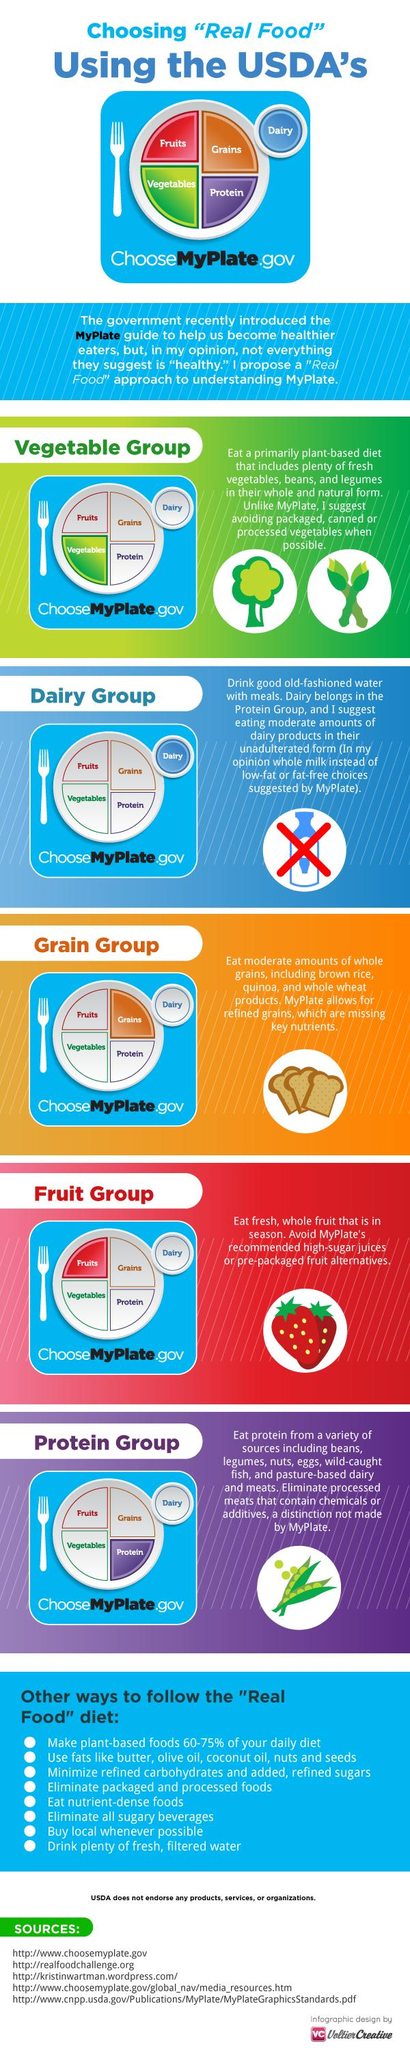Give some essential details in this illustration. The third food group mentioned in the graphic is the Grain group. Eggs are classified under the protein food group. The food group that has been represented by the color green in the image is the vegetable group. Processed meats that contain chemicals or additives should be eliminated from the protein category. The fruit group contains an image of strawberries. 